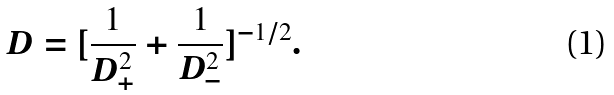<formula> <loc_0><loc_0><loc_500><loc_500>D = [ \frac { 1 } { D _ { + } ^ { 2 } } + \frac { 1 } { D _ { - } ^ { 2 } } ] ^ { - 1 / 2 } .</formula> 